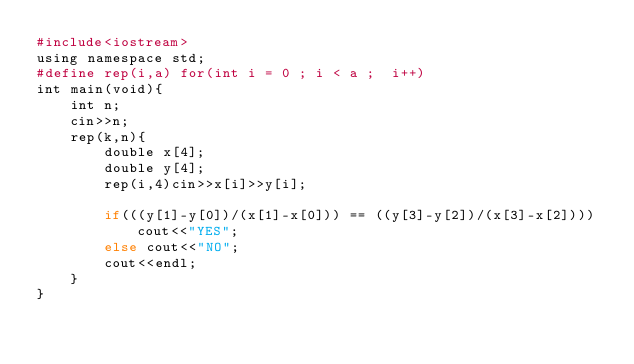Convert code to text. <code><loc_0><loc_0><loc_500><loc_500><_Ruby_>#include<iostream>
using namespace std;
#define rep(i,a) for(int i = 0 ; i < a ;  i++)
int main(void){
	int n;
	cin>>n;
	rep(k,n){
		double x[4];
		double y[4];
		rep(i,4)cin>>x[i]>>y[i];
    
		if(((y[1]-y[0])/(x[1]-x[0])) == ((y[3]-y[2])/(x[3]-x[2])))cout<<"YES";
		else cout<<"NO";
		cout<<endl;
	}
}</code> 